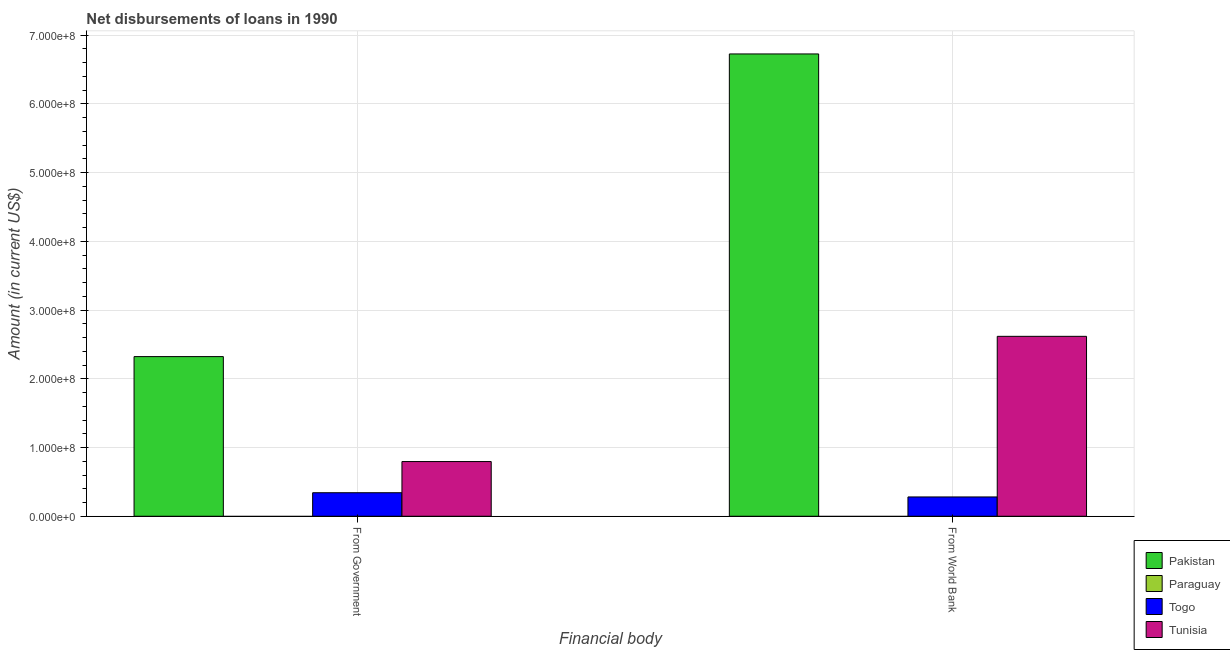Are the number of bars on each tick of the X-axis equal?
Your answer should be compact. Yes. What is the label of the 2nd group of bars from the left?
Your response must be concise. From World Bank. What is the net disbursements of loan from world bank in Pakistan?
Provide a short and direct response. 6.73e+08. Across all countries, what is the maximum net disbursements of loan from world bank?
Provide a short and direct response. 6.73e+08. Across all countries, what is the minimum net disbursements of loan from world bank?
Keep it short and to the point. 0. What is the total net disbursements of loan from world bank in the graph?
Your response must be concise. 9.63e+08. What is the difference between the net disbursements of loan from world bank in Pakistan and that in Togo?
Ensure brevity in your answer.  6.45e+08. What is the difference between the net disbursements of loan from world bank in Tunisia and the net disbursements of loan from government in Togo?
Your answer should be compact. 2.28e+08. What is the average net disbursements of loan from world bank per country?
Your answer should be compact. 2.41e+08. What is the difference between the net disbursements of loan from world bank and net disbursements of loan from government in Pakistan?
Your answer should be compact. 4.40e+08. In how many countries, is the net disbursements of loan from world bank greater than 620000000 US$?
Provide a short and direct response. 1. What is the ratio of the net disbursements of loan from government in Tunisia to that in Togo?
Offer a terse response. 2.33. Is the net disbursements of loan from government in Tunisia less than that in Pakistan?
Keep it short and to the point. Yes. How many countries are there in the graph?
Ensure brevity in your answer.  4. What is the difference between two consecutive major ticks on the Y-axis?
Keep it short and to the point. 1.00e+08. Does the graph contain any zero values?
Provide a succinct answer. Yes. Where does the legend appear in the graph?
Ensure brevity in your answer.  Bottom right. How many legend labels are there?
Your response must be concise. 4. How are the legend labels stacked?
Make the answer very short. Vertical. What is the title of the graph?
Make the answer very short. Net disbursements of loans in 1990. Does "Solomon Islands" appear as one of the legend labels in the graph?
Ensure brevity in your answer.  No. What is the label or title of the X-axis?
Your response must be concise. Financial body. What is the Amount (in current US$) in Pakistan in From Government?
Provide a short and direct response. 2.32e+08. What is the Amount (in current US$) in Togo in From Government?
Ensure brevity in your answer.  3.42e+07. What is the Amount (in current US$) in Tunisia in From Government?
Make the answer very short. 7.96e+07. What is the Amount (in current US$) in Pakistan in From World Bank?
Your answer should be compact. 6.73e+08. What is the Amount (in current US$) of Togo in From World Bank?
Provide a short and direct response. 2.81e+07. What is the Amount (in current US$) in Tunisia in From World Bank?
Keep it short and to the point. 2.62e+08. Across all Financial body, what is the maximum Amount (in current US$) of Pakistan?
Make the answer very short. 6.73e+08. Across all Financial body, what is the maximum Amount (in current US$) of Togo?
Make the answer very short. 3.42e+07. Across all Financial body, what is the maximum Amount (in current US$) in Tunisia?
Keep it short and to the point. 2.62e+08. Across all Financial body, what is the minimum Amount (in current US$) of Pakistan?
Provide a succinct answer. 2.32e+08. Across all Financial body, what is the minimum Amount (in current US$) of Togo?
Offer a very short reply. 2.81e+07. Across all Financial body, what is the minimum Amount (in current US$) in Tunisia?
Your answer should be compact. 7.96e+07. What is the total Amount (in current US$) of Pakistan in the graph?
Make the answer very short. 9.05e+08. What is the total Amount (in current US$) in Paraguay in the graph?
Offer a terse response. 0. What is the total Amount (in current US$) of Togo in the graph?
Provide a short and direct response. 6.23e+07. What is the total Amount (in current US$) in Tunisia in the graph?
Your answer should be compact. 3.41e+08. What is the difference between the Amount (in current US$) in Pakistan in From Government and that in From World Bank?
Keep it short and to the point. -4.40e+08. What is the difference between the Amount (in current US$) of Togo in From Government and that in From World Bank?
Your response must be concise. 6.13e+06. What is the difference between the Amount (in current US$) of Tunisia in From Government and that in From World Bank?
Your answer should be very brief. -1.82e+08. What is the difference between the Amount (in current US$) of Pakistan in From Government and the Amount (in current US$) of Togo in From World Bank?
Your answer should be compact. 2.04e+08. What is the difference between the Amount (in current US$) of Pakistan in From Government and the Amount (in current US$) of Tunisia in From World Bank?
Ensure brevity in your answer.  -2.95e+07. What is the difference between the Amount (in current US$) in Togo in From Government and the Amount (in current US$) in Tunisia in From World Bank?
Provide a short and direct response. -2.28e+08. What is the average Amount (in current US$) in Pakistan per Financial body?
Your answer should be very brief. 4.53e+08. What is the average Amount (in current US$) in Paraguay per Financial body?
Provide a succinct answer. 0. What is the average Amount (in current US$) of Togo per Financial body?
Offer a very short reply. 3.12e+07. What is the average Amount (in current US$) of Tunisia per Financial body?
Your response must be concise. 1.71e+08. What is the difference between the Amount (in current US$) of Pakistan and Amount (in current US$) of Togo in From Government?
Your response must be concise. 1.98e+08. What is the difference between the Amount (in current US$) of Pakistan and Amount (in current US$) of Tunisia in From Government?
Ensure brevity in your answer.  1.53e+08. What is the difference between the Amount (in current US$) of Togo and Amount (in current US$) of Tunisia in From Government?
Offer a terse response. -4.54e+07. What is the difference between the Amount (in current US$) in Pakistan and Amount (in current US$) in Togo in From World Bank?
Your answer should be compact. 6.45e+08. What is the difference between the Amount (in current US$) in Pakistan and Amount (in current US$) in Tunisia in From World Bank?
Your answer should be very brief. 4.11e+08. What is the difference between the Amount (in current US$) of Togo and Amount (in current US$) of Tunisia in From World Bank?
Your answer should be very brief. -2.34e+08. What is the ratio of the Amount (in current US$) in Pakistan in From Government to that in From World Bank?
Ensure brevity in your answer.  0.35. What is the ratio of the Amount (in current US$) of Togo in From Government to that in From World Bank?
Make the answer very short. 1.22. What is the ratio of the Amount (in current US$) of Tunisia in From Government to that in From World Bank?
Offer a terse response. 0.3. What is the difference between the highest and the second highest Amount (in current US$) in Pakistan?
Give a very brief answer. 4.40e+08. What is the difference between the highest and the second highest Amount (in current US$) in Togo?
Your response must be concise. 6.13e+06. What is the difference between the highest and the second highest Amount (in current US$) in Tunisia?
Make the answer very short. 1.82e+08. What is the difference between the highest and the lowest Amount (in current US$) of Pakistan?
Your answer should be compact. 4.40e+08. What is the difference between the highest and the lowest Amount (in current US$) in Togo?
Keep it short and to the point. 6.13e+06. What is the difference between the highest and the lowest Amount (in current US$) of Tunisia?
Keep it short and to the point. 1.82e+08. 